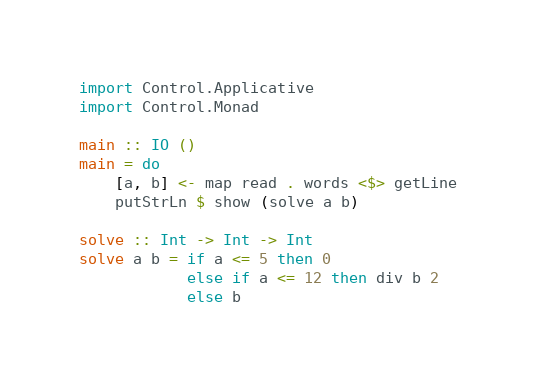Convert code to text. <code><loc_0><loc_0><loc_500><loc_500><_Haskell_>import Control.Applicative
import Control.Monad
 
main :: IO ()
main = do
    [a, b] <- map read . words <$> getLine
    putStrLn $ show (solve a b)
    
solve :: Int -> Int -> Int 
solve a b = if a <= 5 then 0
            else if a <= 12 then div b 2
            else b</code> 